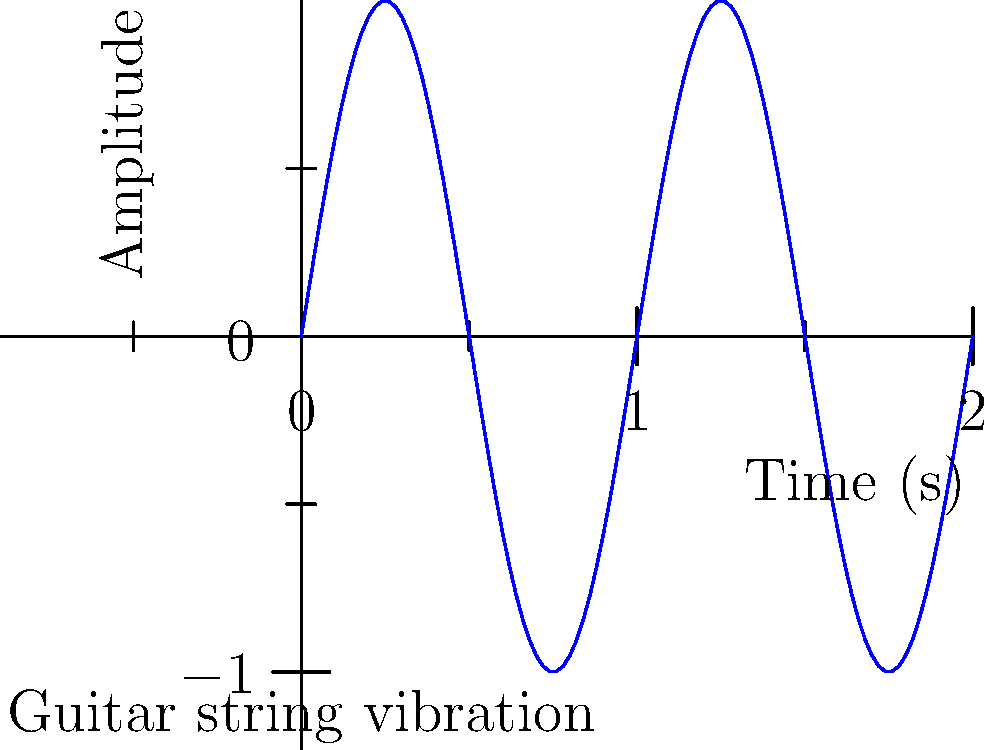In the graph above, which represents the vibration of a guitar string over time, how many complete cycles (periods) of the sine wave are shown? Relate this to the fundamental frequency of a typical Leb i Sol guitar riff. To answer this question, we need to follow these steps:

1. Understand that one complete cycle of a sine wave goes from peak to peak or trough to trough.

2. Count the number of complete cycles in the graph:
   - The wave starts at (0,0), reaches a peak, goes to a trough, and back to the starting point at x = 1.
   - This pattern repeats once more from x = 1 to x = 2.

3. We can see that there are 2 complete cycles in the graph.

4. Relate this to guitar string vibration:
   - Each cycle represents one complete vibration of the guitar string.
   - The number of cycles per second determines the pitch (frequency) of the note.

5. For a typical Leb i Sol guitar riff:
   - Let's assume a common note in their music, like an open E string (82.41 Hz).
   - This means the E string vibrates 82.41 times per second.

6. In our graph:
   - If 2 cycles occur in 2 seconds, the frequency would be 1 Hz.
   - This is much lower than a real guitar string, but it allows us to visualize the wave clearly.

7. The fundamental frequency of a guitar string is inversely proportional to its length. Shorter strings (fretted notes) produce higher frequencies, while longer strings (open strings) produce lower frequencies.
Answer: 2 cycles; lower frequency than typical guitar strings for clearer visualization 